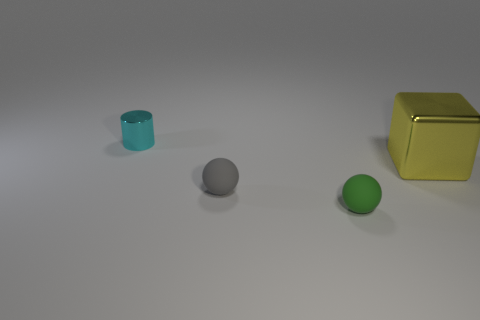Add 1 large yellow blocks. How many objects exist? 5 Subtract all cylinders. How many objects are left? 3 Add 1 small things. How many small things exist? 4 Subtract 1 green spheres. How many objects are left? 3 Subtract all cubes. Subtract all tiny matte balls. How many objects are left? 1 Add 2 balls. How many balls are left? 4 